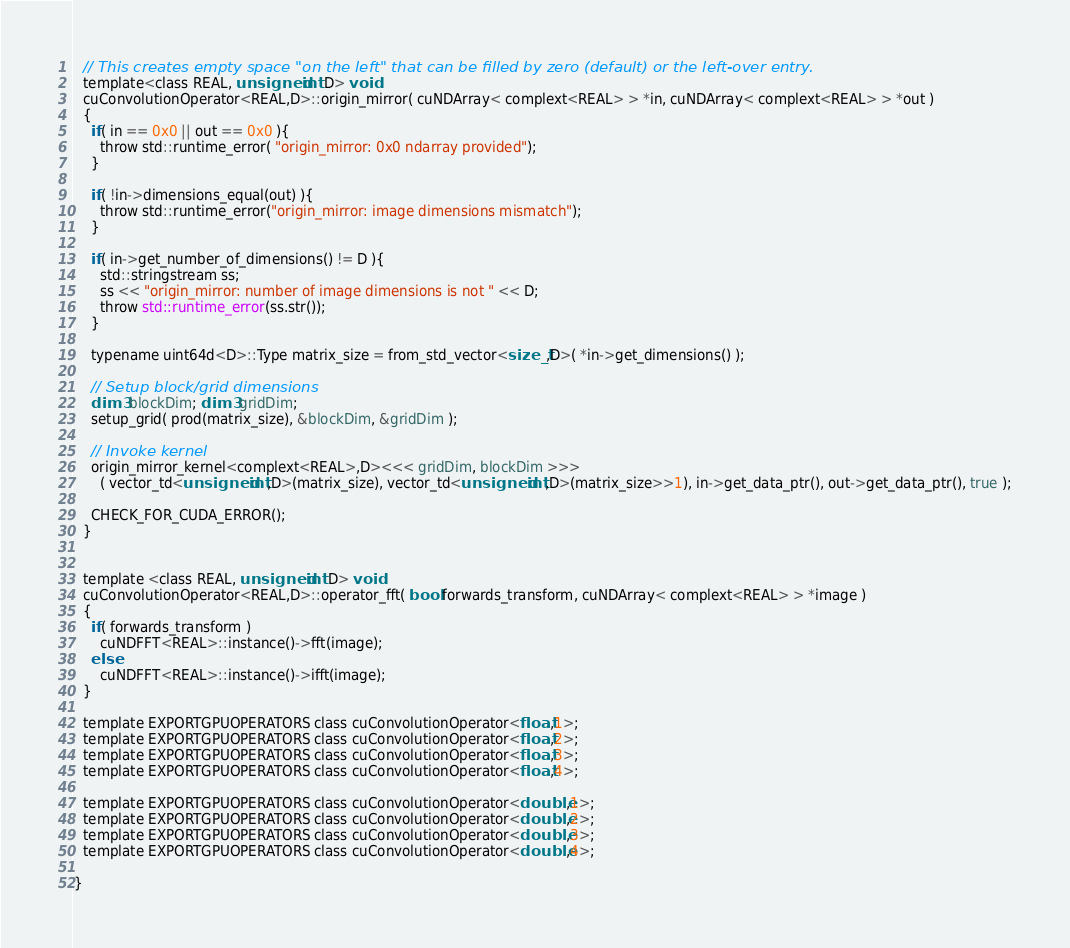<code> <loc_0><loc_0><loc_500><loc_500><_Cuda_>  // This creates empty space "on the left" that can be filled by zero (default) or the left-over entry.
  template<class REAL, unsigned int D> void
  cuConvolutionOperator<REAL,D>::origin_mirror( cuNDArray< complext<REAL> > *in, cuNDArray< complext<REAL> > *out )
  {
    if( in == 0x0 || out == 0x0 ){
      throw std::runtime_error( "origin_mirror: 0x0 ndarray provided");
    }
    
    if( !in->dimensions_equal(out) ){
      throw std::runtime_error("origin_mirror: image dimensions mismatch");
    }
    
    if( in->get_number_of_dimensions() != D ){
      std::stringstream ss;
      ss << "origin_mirror: number of image dimensions is not " << D;
      throw std::runtime_error(ss.str());
    }

    typename uint64d<D>::Type matrix_size = from_std_vector<size_t,D>( *in->get_dimensions() );
  
    // Setup block/grid dimensions
    dim3 blockDim; dim3 gridDim;
    setup_grid( prod(matrix_size), &blockDim, &gridDim );

    // Invoke kernel
    origin_mirror_kernel<complext<REAL>,D><<< gridDim, blockDim >>> 
      ( vector_td<unsigned int,D>(matrix_size), vector_td<unsigned int,D>(matrix_size>>1), in->get_data_ptr(), out->get_data_ptr(), true );
    
    CHECK_FOR_CUDA_ERROR();
  }


  template <class REAL, unsigned int D> void 
  cuConvolutionOperator<REAL,D>::operator_fft( bool forwards_transform, cuNDArray< complext<REAL> > *image )
  {
    if( forwards_transform )
      cuNDFFT<REAL>::instance()->fft(image);
    else
      cuNDFFT<REAL>::instance()->ifft(image);
  }    
  
  template EXPORTGPUOPERATORS class cuConvolutionOperator<float,1>;
  template EXPORTGPUOPERATORS class cuConvolutionOperator<float,2>;
  template EXPORTGPUOPERATORS class cuConvolutionOperator<float,3>;
  template EXPORTGPUOPERATORS class cuConvolutionOperator<float,4>;

  template EXPORTGPUOPERATORS class cuConvolutionOperator<double,1>;
  template EXPORTGPUOPERATORS class cuConvolutionOperator<double,2>;
  template EXPORTGPUOPERATORS class cuConvolutionOperator<double,3>;
  template EXPORTGPUOPERATORS class cuConvolutionOperator<double,4>;
  
}
</code> 